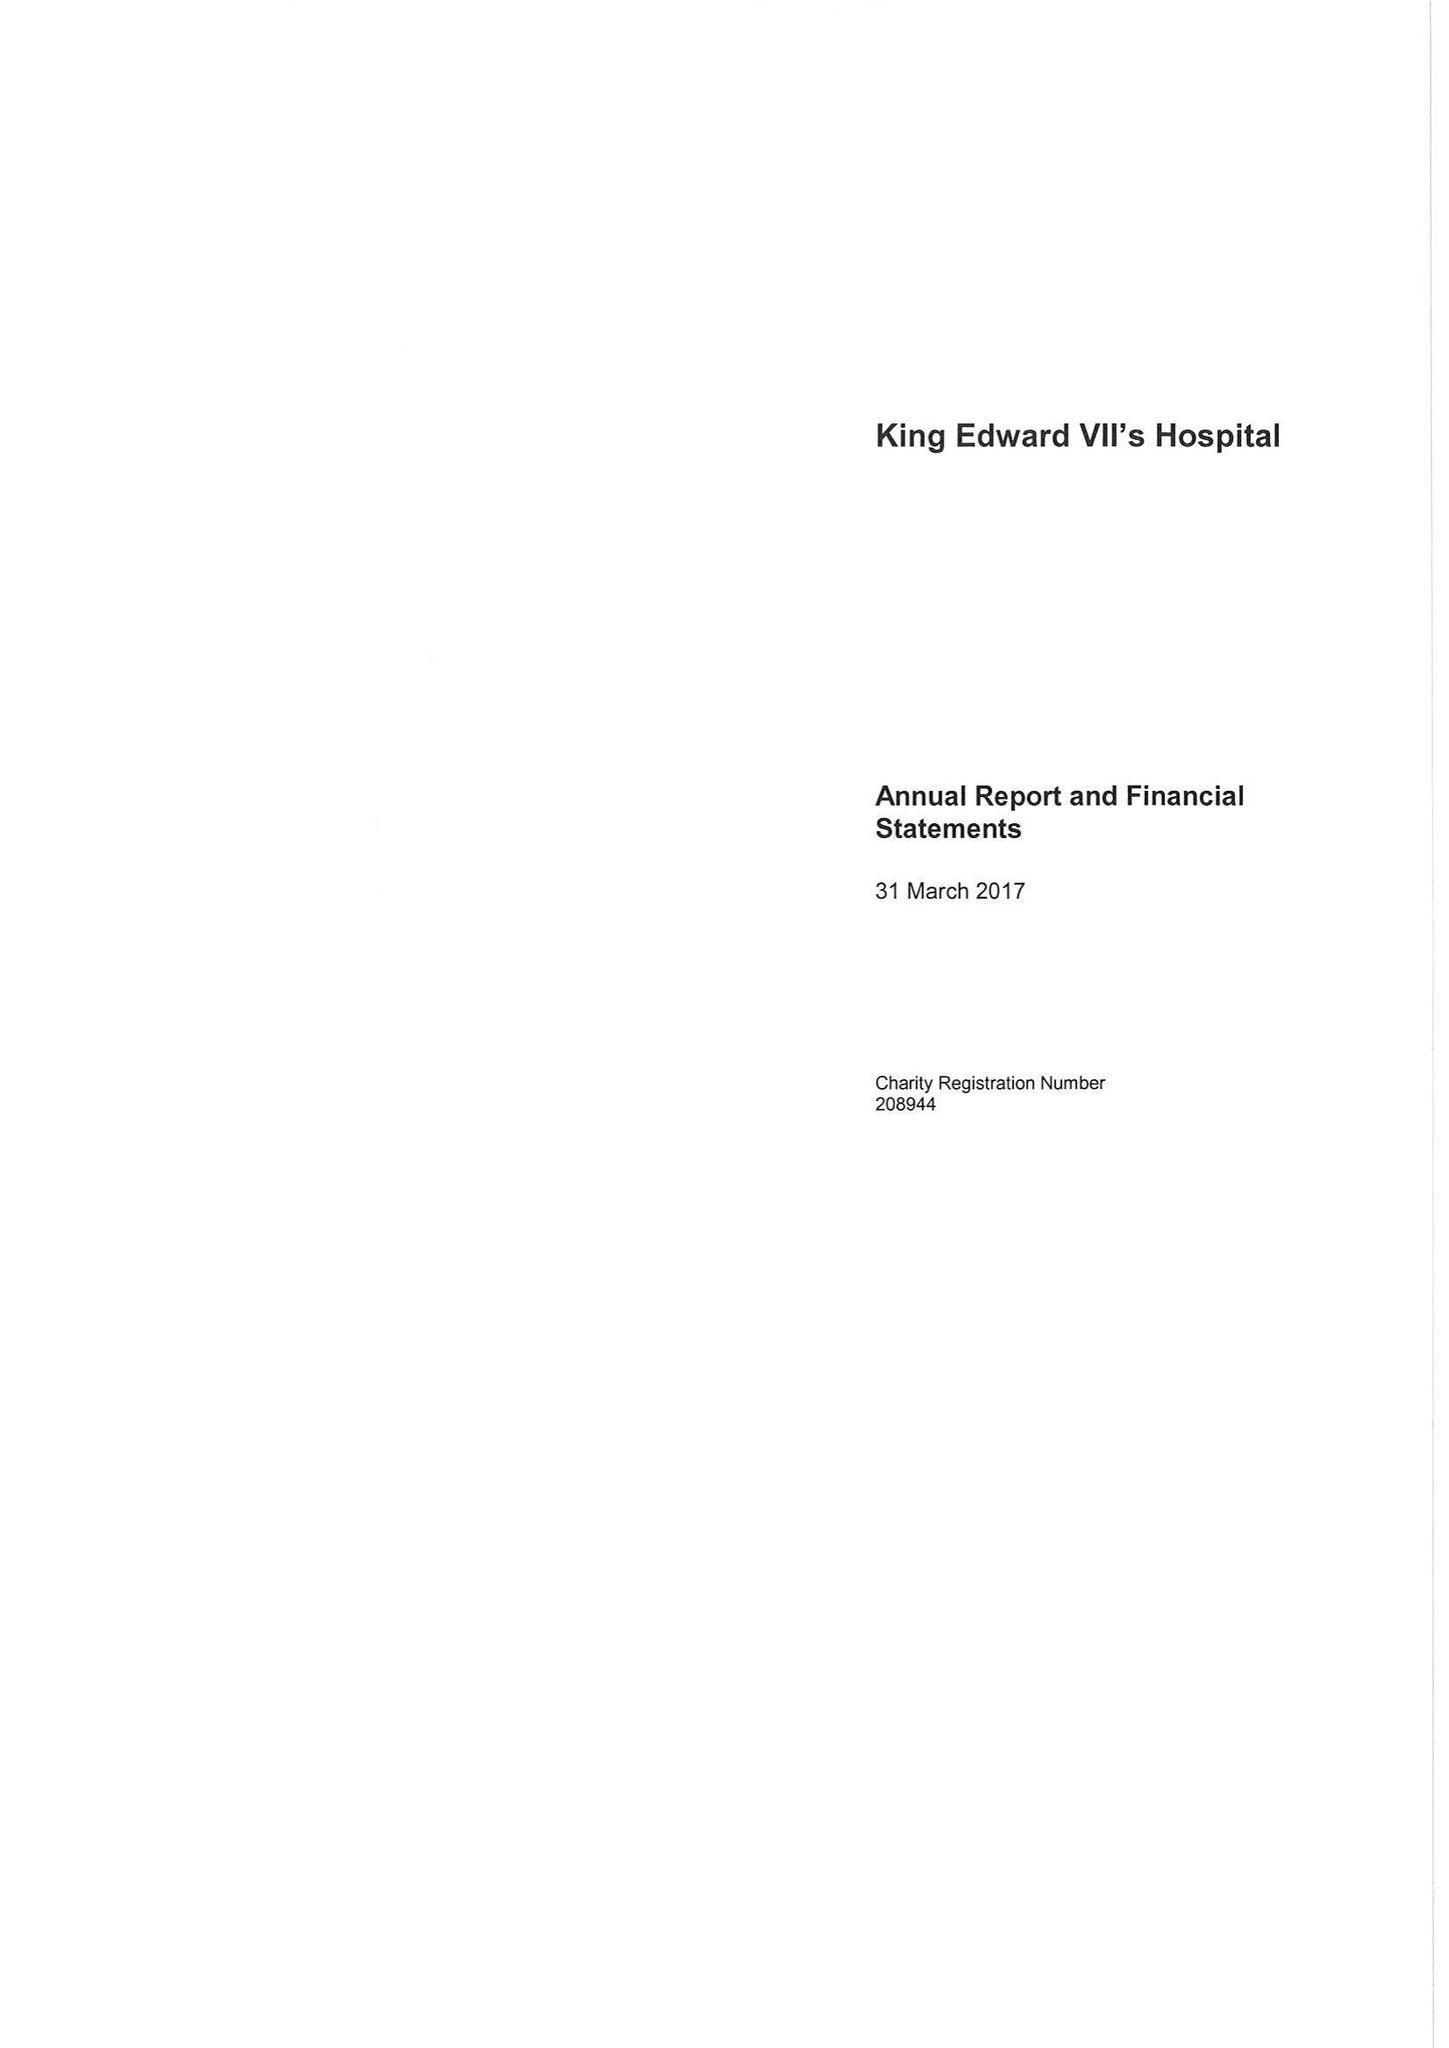What is the value for the report_date?
Answer the question using a single word or phrase. 2017-03-31 